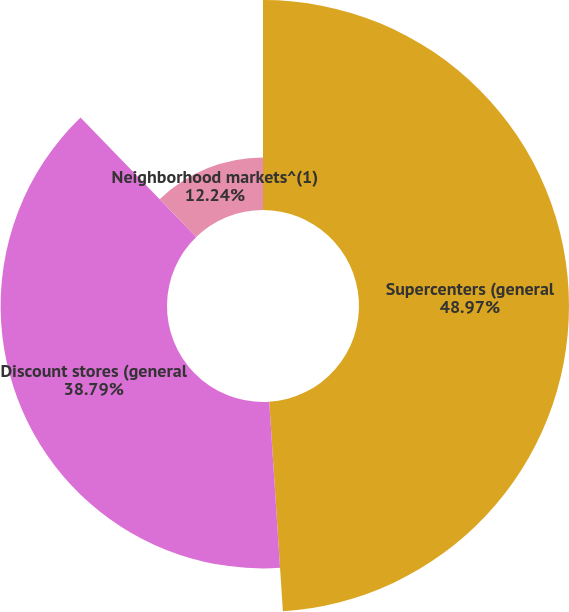Convert chart to OTSL. <chart><loc_0><loc_0><loc_500><loc_500><pie_chart><fcel>Supercenters (general<fcel>Discount stores (general<fcel>Neighborhood markets^(1)<nl><fcel>48.96%<fcel>38.79%<fcel>12.24%<nl></chart> 